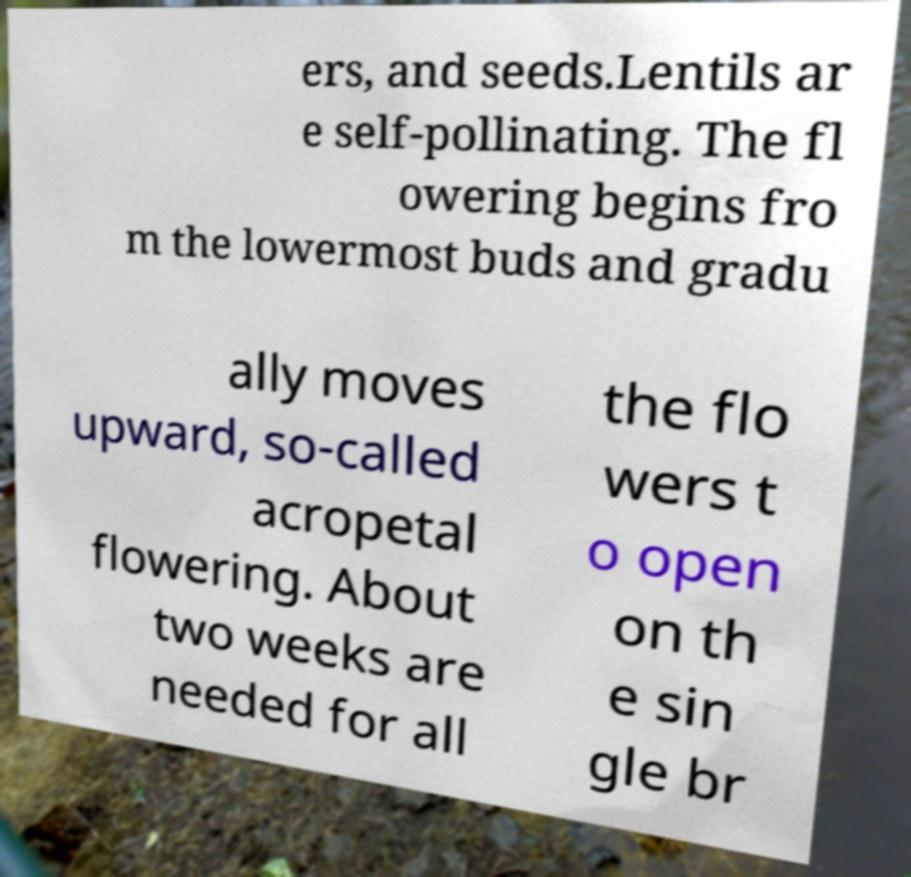Please read and relay the text visible in this image. What does it say? ers, and seeds.Lentils ar e self-pollinating. The fl owering begins fro m the lowermost buds and gradu ally moves upward, so-called acropetal flowering. About two weeks are needed for all the flo wers t o open on th e sin gle br 